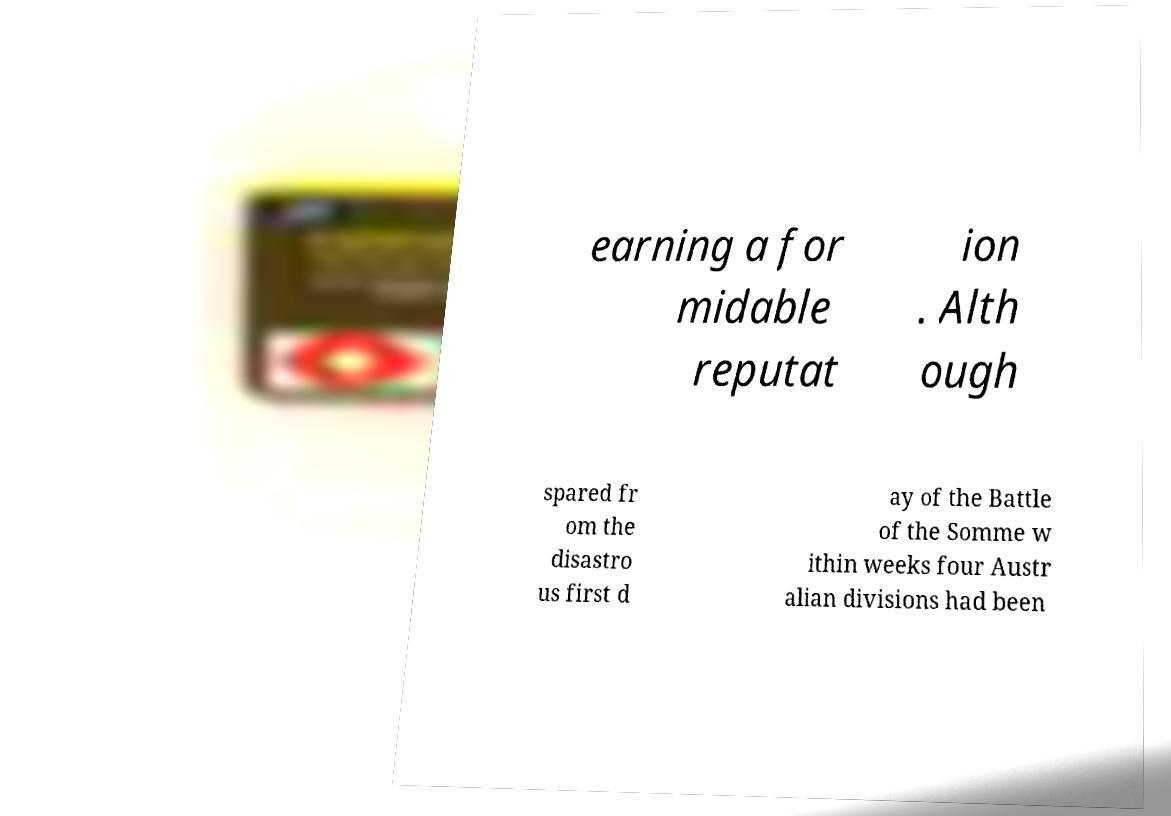Please identify and transcribe the text found in this image. earning a for midable reputat ion . Alth ough spared fr om the disastro us first d ay of the Battle of the Somme w ithin weeks four Austr alian divisions had been 